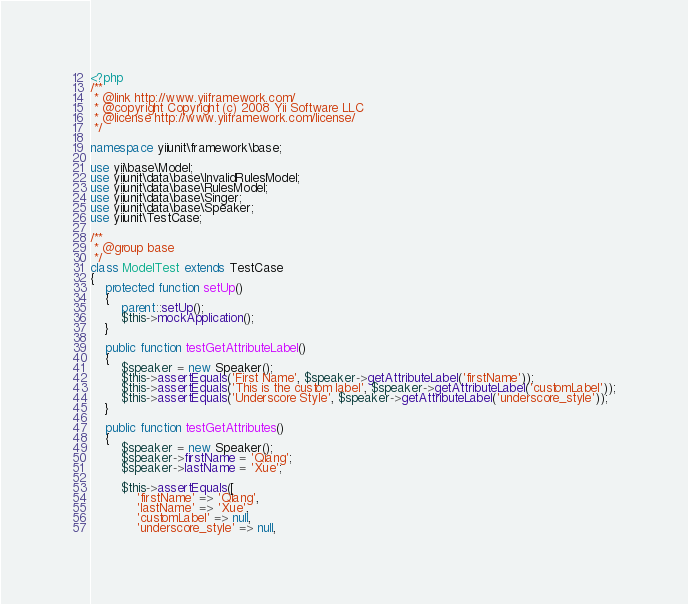<code> <loc_0><loc_0><loc_500><loc_500><_PHP_><?php
/**
 * @link http://www.yiiframework.com/
 * @copyright Copyright (c) 2008 Yii Software LLC
 * @license http://www.yiiframework.com/license/
 */

namespace yiiunit\framework\base;

use yii\base\Model;
use yiiunit\data\base\InvalidRulesModel;
use yiiunit\data\base\RulesModel;
use yiiunit\data\base\Singer;
use yiiunit\data\base\Speaker;
use yiiunit\TestCase;

/**
 * @group base
 */
class ModelTest extends TestCase
{
    protected function setUp()
    {
        parent::setUp();
        $this->mockApplication();
    }

    public function testGetAttributeLabel()
    {
        $speaker = new Speaker();
        $this->assertEquals('First Name', $speaker->getAttributeLabel('firstName'));
        $this->assertEquals('This is the custom label', $speaker->getAttributeLabel('customLabel'));
        $this->assertEquals('Underscore Style', $speaker->getAttributeLabel('underscore_style'));
    }

    public function testGetAttributes()
    {
        $speaker = new Speaker();
        $speaker->firstName = 'Qiang';
        $speaker->lastName = 'Xue';

        $this->assertEquals([
            'firstName' => 'Qiang',
            'lastName' => 'Xue',
            'customLabel' => null,
            'underscore_style' => null,</code> 